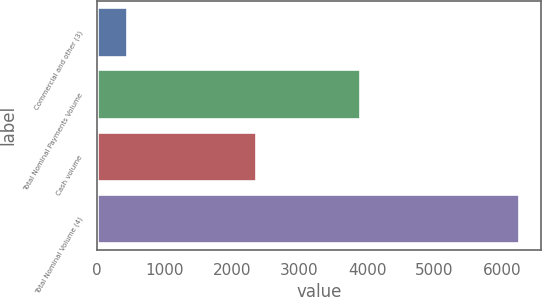<chart> <loc_0><loc_0><loc_500><loc_500><bar_chart><fcel>Commercial and other (3)<fcel>Total Nominal Payments Volume<fcel>Cash volume<fcel>Total Nominal Volume (4)<nl><fcel>440<fcel>3900<fcel>2357<fcel>6257<nl></chart> 